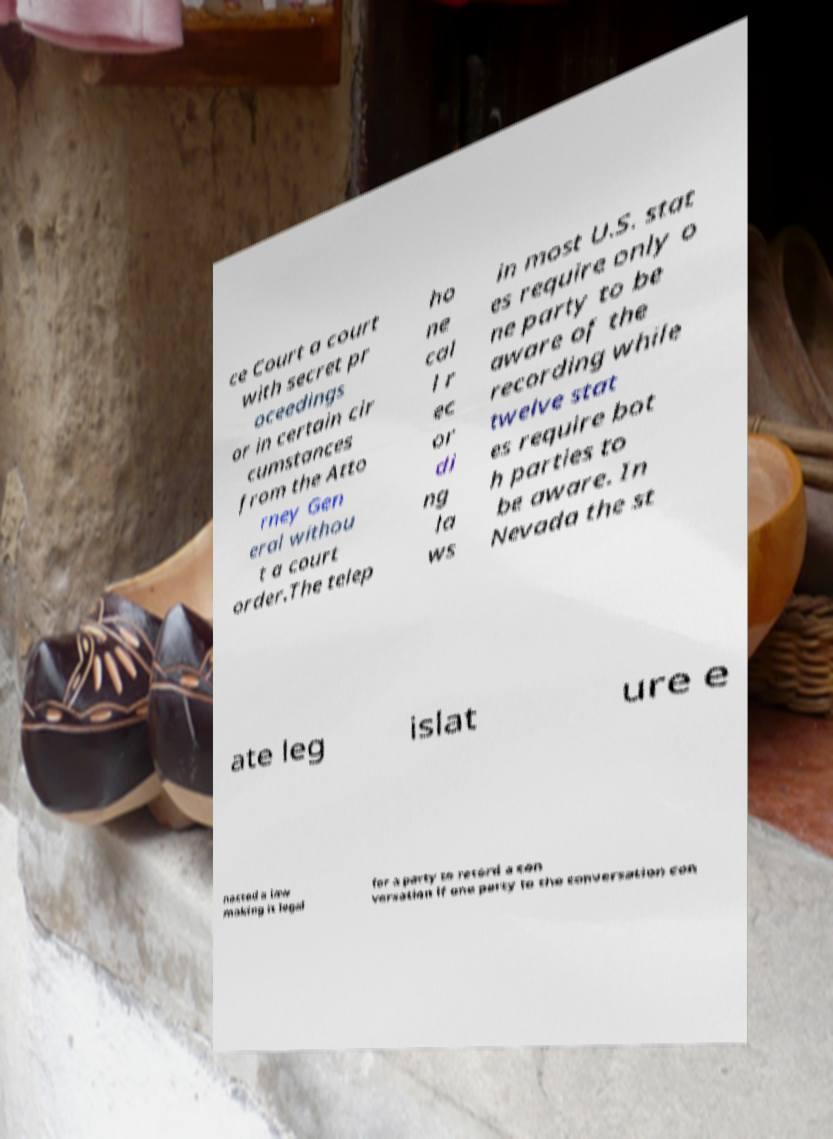I need the written content from this picture converted into text. Can you do that? ce Court a court with secret pr oceedings or in certain cir cumstances from the Atto rney Gen eral withou t a court order.The telep ho ne cal l r ec or di ng la ws in most U.S. stat es require only o ne party to be aware of the recording while twelve stat es require bot h parties to be aware. In Nevada the st ate leg islat ure e nacted a law making it legal for a party to record a con versation if one party to the conversation con 